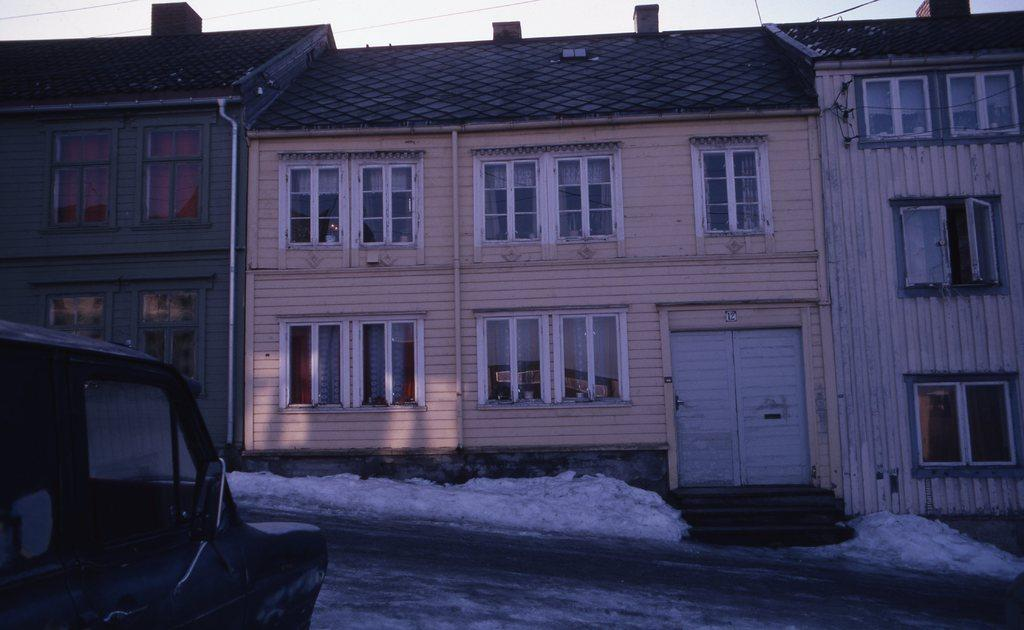What type of structure is present in the image? There is a building in the image. What feature of the building is mentioned in the facts? The building has many windows. What is located in front of the building on the road? There is a car in front of the building on the road. What can be seen above the building in the image? The sky is visible above the building. What time of day is it in the image, and is there a volleyball game happening? The time of day is not mentioned in the facts, and there is no indication of a volleyball game happening in the image. 